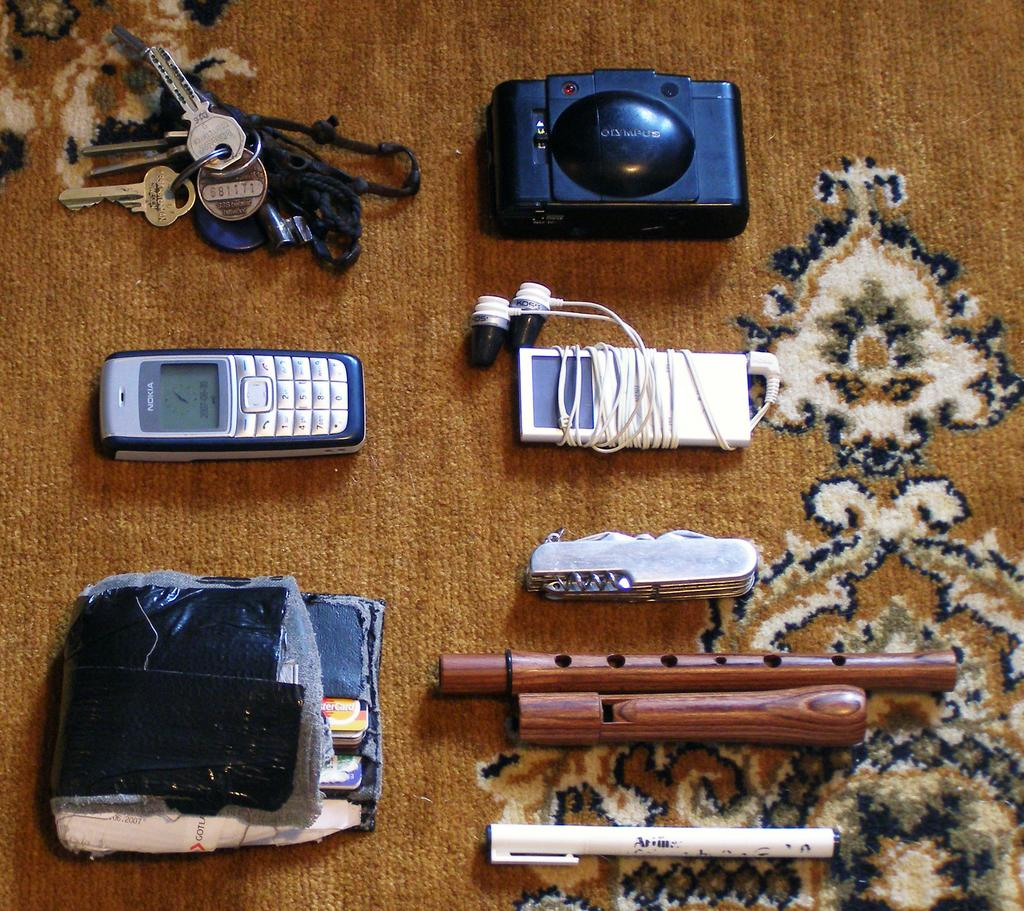What electronic devices can be seen in the image? There is a mobile phone, an iPod with earphones, and a camera in the image. What other personal items are visible in the image? There are keys, a wallet, and other unspecified objects in the image. What type of hose is being used to water the plants in the image? There is no hose or plants present in the image. Can you tell me who won the argument in the image? There is no argument or people present in the image. 